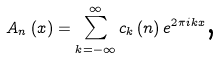Convert formula to latex. <formula><loc_0><loc_0><loc_500><loc_500>A _ { n } \left ( x \right ) = \sum _ { k = - \infty } ^ { \infty } c _ { k } \left ( n \right ) e ^ { 2 \pi i k x } \text {,}</formula> 